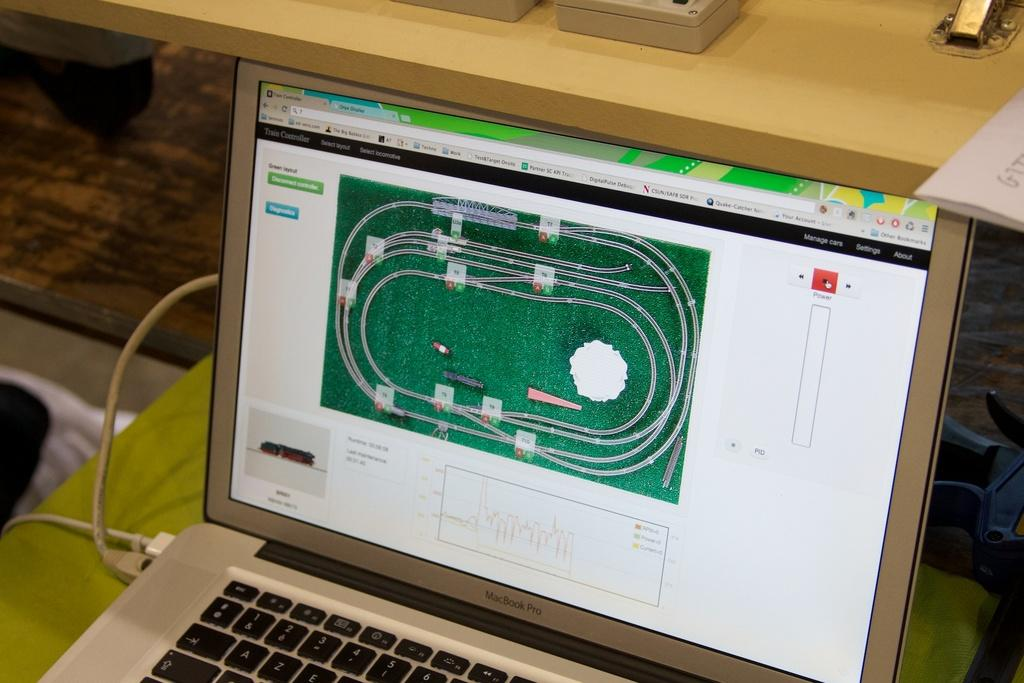<image>
Describe the image concisely. Macbook Pro screen showing a race track being edited. 